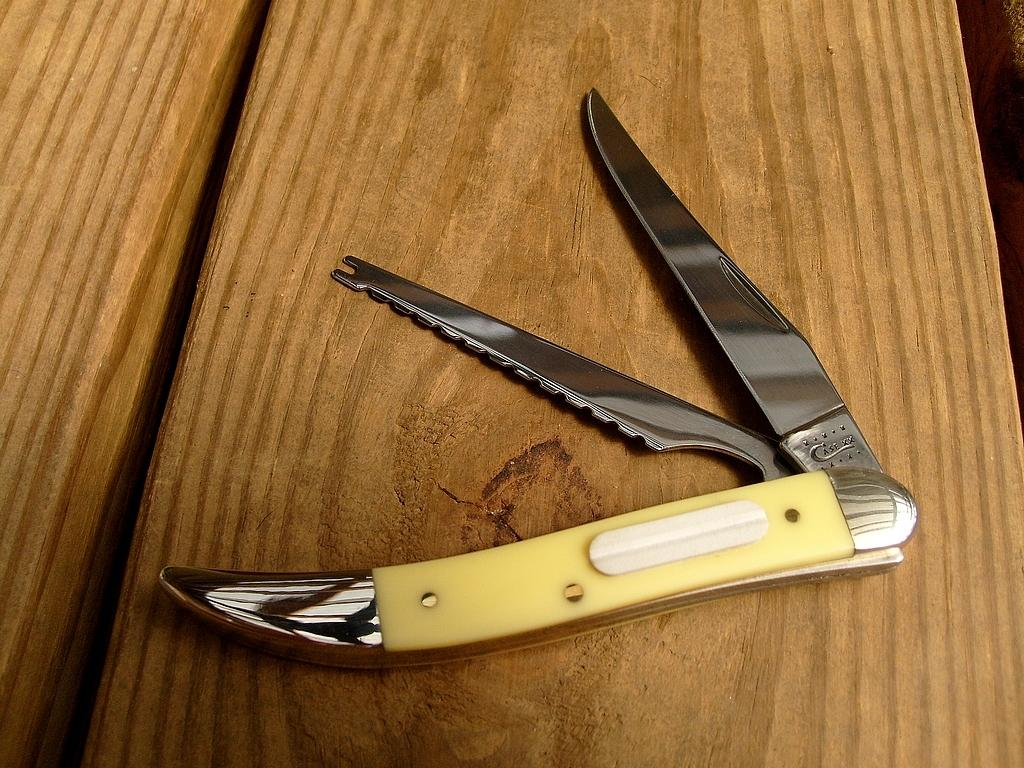What objects are present in the image? There are knives in the image. Where are the knives located? The knives are placed on a table. What type of invention is being demonstrated with the knives in the image? There is no invention being demonstrated with the knives in the image; they are simply placed on a table. How many fingers are visible holding the knives in the image? There are no fingers visible in the image, as the knives are placed on a table without any hands or fingers holding them. 